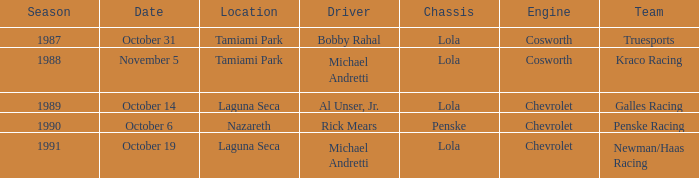Parse the table in full. {'header': ['Season', 'Date', 'Location', 'Driver', 'Chassis', 'Engine', 'Team'], 'rows': [['1987', 'October 31', 'Tamiami Park', 'Bobby Rahal', 'Lola', 'Cosworth', 'Truesports'], ['1988', 'November 5', 'Tamiami Park', 'Michael Andretti', 'Lola', 'Cosworth', 'Kraco Racing'], ['1989', 'October 14', 'Laguna Seca', 'Al Unser, Jr.', 'Lola', 'Chevrolet', 'Galles Racing'], ['1990', 'October 6', 'Nazareth', 'Rick Mears', 'Penske', 'Chevrolet', 'Penske Racing'], ['1991', 'October 19', 'Laguna Seca', 'Michael Andretti', 'Lola', 'Chevrolet', 'Newman/Haas Racing']]} What was the date of the race in nazareth? October 6. 